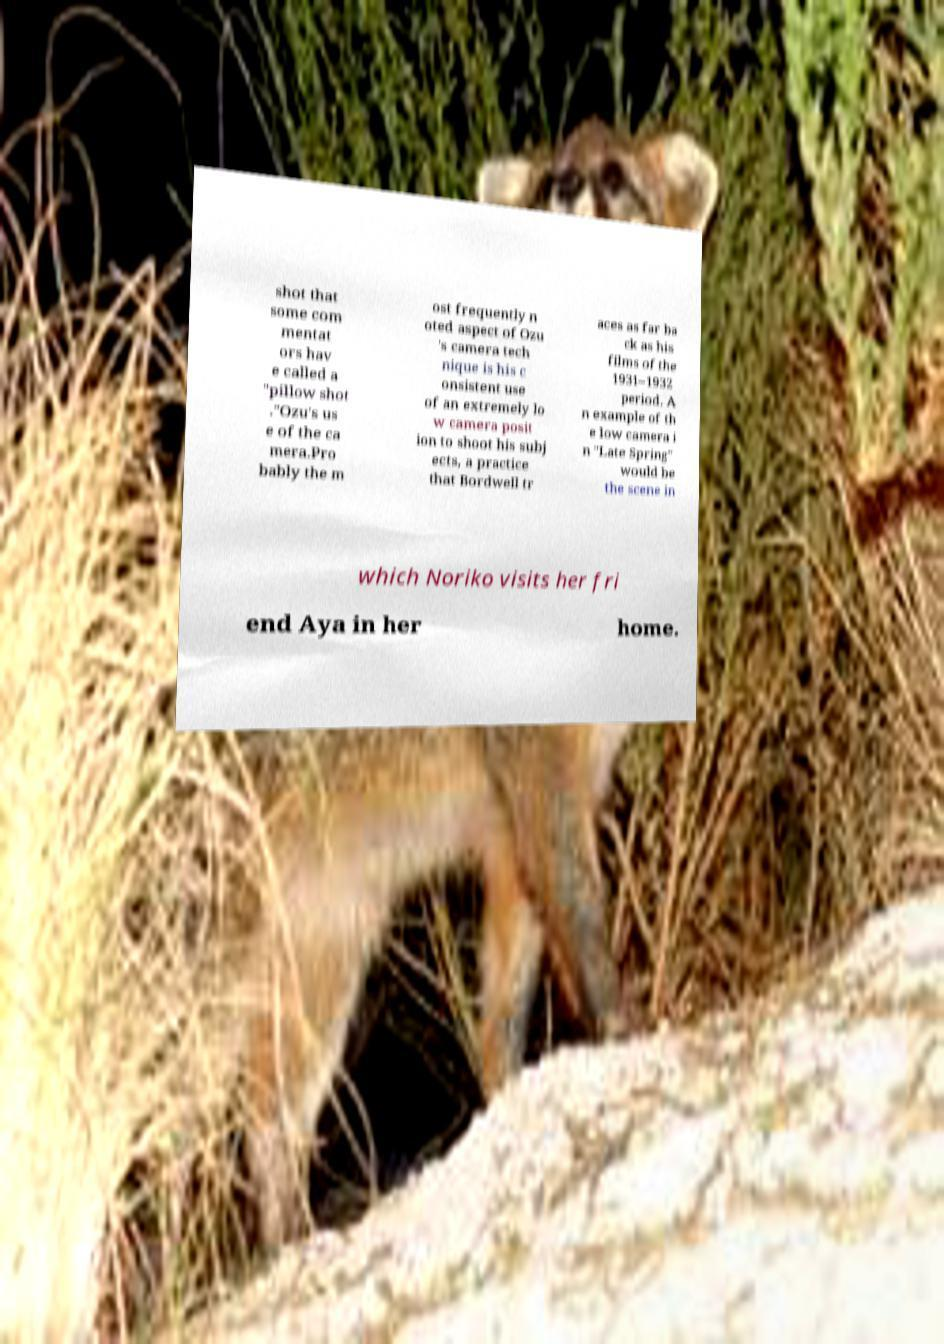What messages or text are displayed in this image? I need them in a readable, typed format. shot that some com mentat ors hav e called a "pillow shot ."Ozu's us e of the ca mera.Pro bably the m ost frequently n oted aspect of Ozu 's camera tech nique is his c onsistent use of an extremely lo w camera posit ion to shoot his subj ects, a practice that Bordwell tr aces as far ba ck as his films of the 1931–1932 period. A n example of th e low camera i n "Late Spring" would be the scene in which Noriko visits her fri end Aya in her home. 